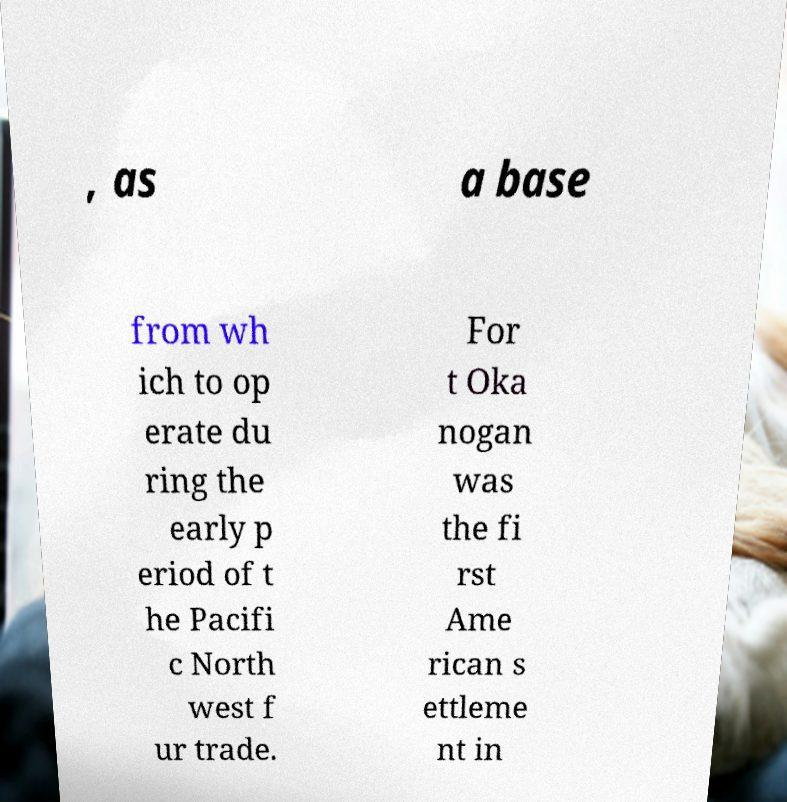I need the written content from this picture converted into text. Can you do that? , as a base from wh ich to op erate du ring the early p eriod of t he Pacifi c North west f ur trade. For t Oka nogan was the fi rst Ame rican s ettleme nt in 